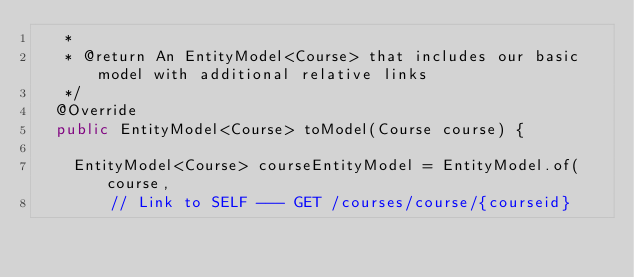<code> <loc_0><loc_0><loc_500><loc_500><_Java_>	 *
	 * @return An EntityModel<Course> that includes our basic model with additional relative links
	 */
	@Override
	public EntityModel<Course> toModel(Course course) {

		EntityModel<Course> courseEntityModel = EntityModel.of(course,
				// Link to SELF --- GET /courses/course/{courseid}</code> 